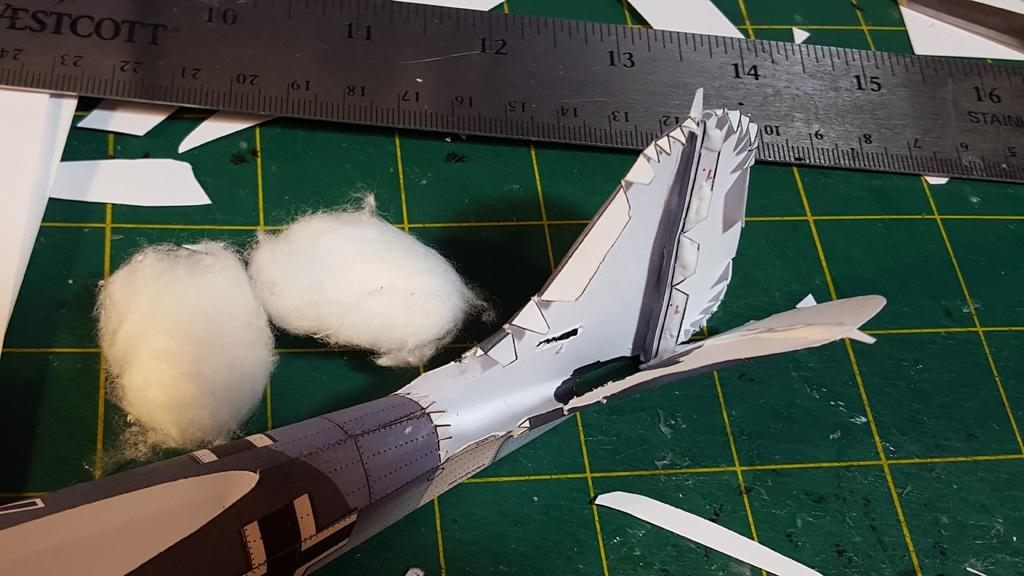What is the main object in the image? There is a scale in the image. What other items can be seen in the image? There are cotton balls in the image. What is the object on the platform in the image? The facts do not specify what the object on the platform is. What type of guitar is being played in the image? There is no guitar present in the image. 